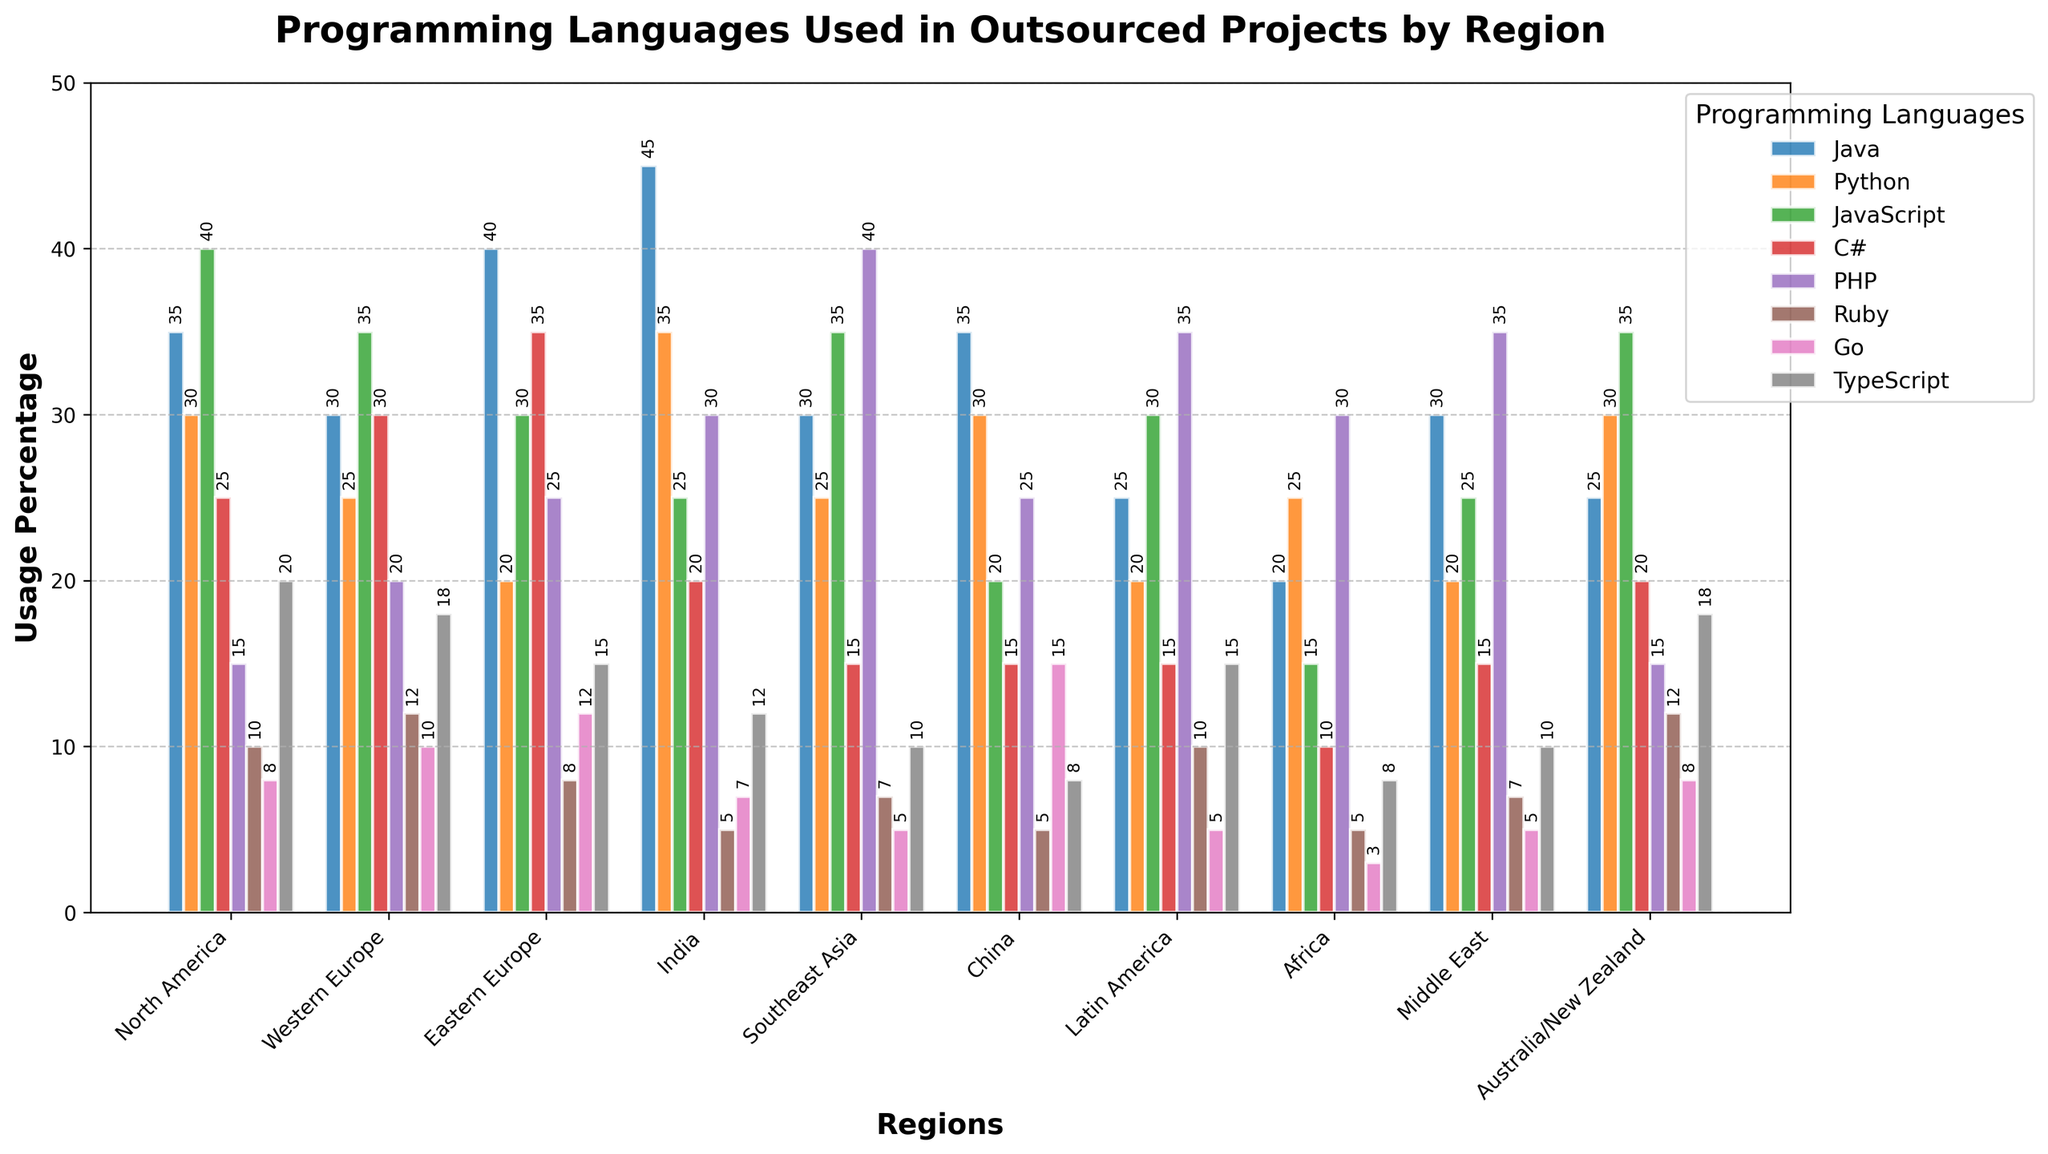Which region uses Java the most? By looking at the heights of the Java bars, the tallest bar is in the India region, indicating the highest usage of Java in that region.
Answer: India Which region has the lowest usage of Go? By comparing the heights of the Go bars, the shortest bar is in the Africa region, indicating the lowest usage of Go in that region.
Answer: Africa How does the usage of Python in North America compare to that in China? By examining the heights of the Python bars for North America and China, it can be seen that they are approximately the same height, indicating similar usage levels.
Answer: Similar Which region has the most balanced usage of programming languages? A balanced usage would roughly mean that the bars for all programming languages are of similar height in this region. Western Europe exhibits such characteristics as the bars don't have drastic differences in height.
Answer: Western Europe What is the sum of the usage percentages for Ruby and TypeScript in Australia/New Zealand? For Australia/New Zealand, add the percentages of Ruby (12) and TypeScript (18) to get the total usage. 12 + 18 = 30.
Answer: 30 What is the region with the highest cumulative usage of all programming languages? To find this, sum up the values for all programming languages in each region and compare them. The region with the highest sum is India, with a total sum of 179.
Answer: India In which region is PHP used more than 30%? By examining the PHP bars for all regions, Southeast Asia, Latin America, and the Middle East have bars exceeding the 30% mark.
Answer: Southeast Asia, Latin America, Middle East Compare the usage of C# between Eastern Europe and Middle East. Which region has the higher usage? By comparing the heights of the C# bars, Eastern Europe’s bar is taller than that of the Middle East, indicating higher usage in Eastern Europe.
Answer: Eastern Europe What is the average usage of JavaScript in all regions? Sum the JavaScript values across all regions (40 + 35 + 30 + 25 + 35 + 20 + 30 + 15 + 25 + 35 = 290) and divide by the number of regions (10), giving an average of 29.
Answer: 29 Is there a region where Go usage exceeds that of Java? By comparing Go and Java bars in each region, there is no region where the Go usage percentage is higher than that of Java.
Answer: No 